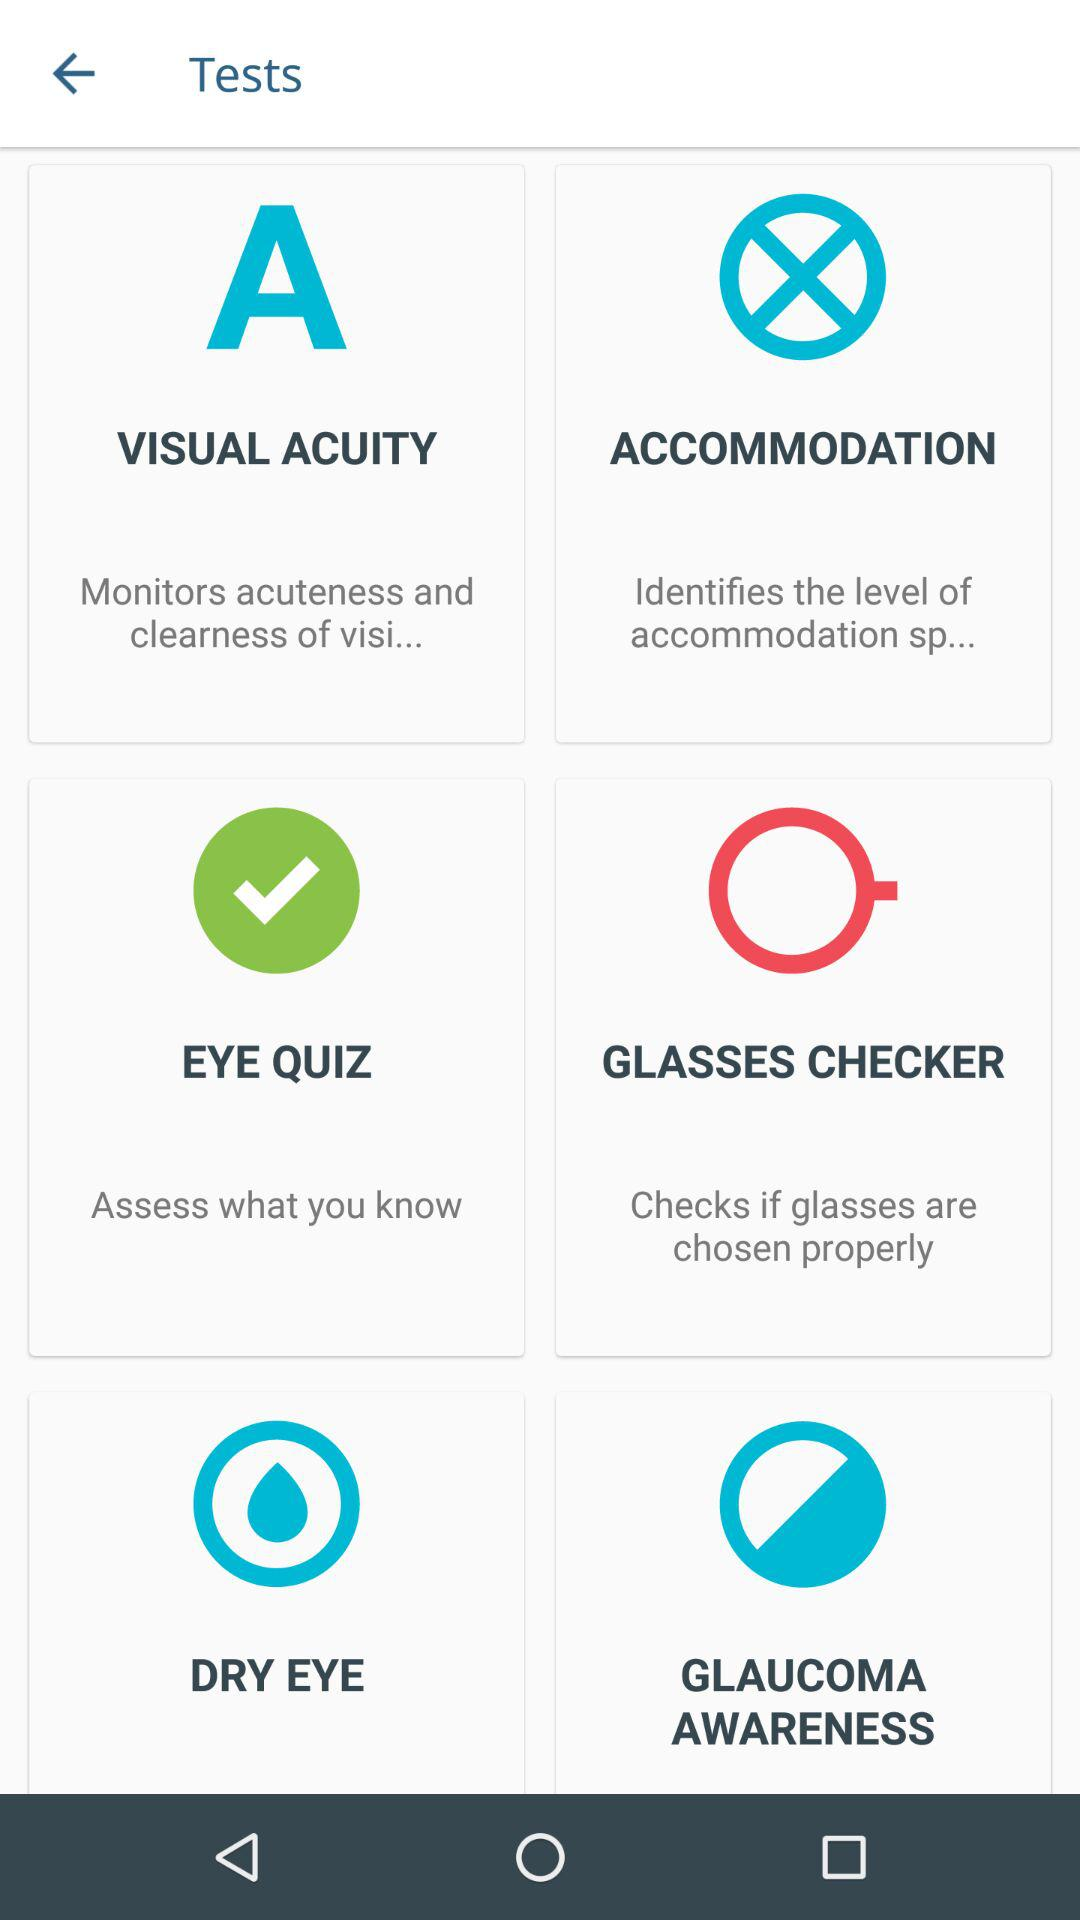What different tests are available? The available tests are "Visual Acuity", "Accommodation", "Eye Quiz", "Glasses Checker", "Dry Eye" and "Glaucoma Awareness". 